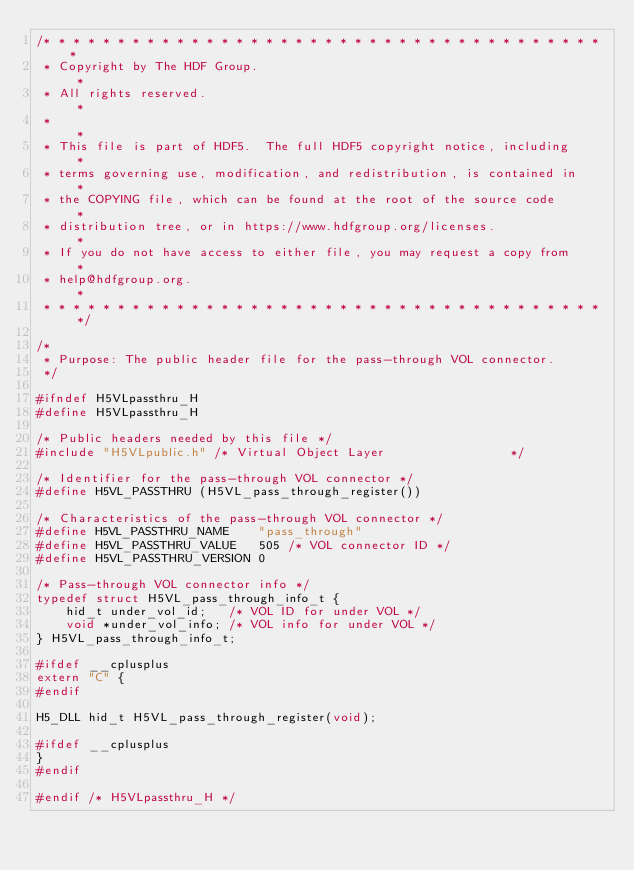Convert code to text. <code><loc_0><loc_0><loc_500><loc_500><_C_>/* * * * * * * * * * * * * * * * * * * * * * * * * * * * * * * * * * * * * * *
 * Copyright by The HDF Group.                                               *
 * All rights reserved.                                                      *
 *                                                                           *
 * This file is part of HDF5.  The full HDF5 copyright notice, including     *
 * terms governing use, modification, and redistribution, is contained in    *
 * the COPYING file, which can be found at the root of the source code       *
 * distribution tree, or in https://www.hdfgroup.org/licenses.               *
 * If you do not have access to either file, you may request a copy from     *
 * help@hdfgroup.org.                                                        *
 * * * * * * * * * * * * * * * * * * * * * * * * * * * * * * * * * * * * * * */

/*
 * Purpose:	The public header file for the pass-through VOL connector.
 */

#ifndef H5VLpassthru_H
#define H5VLpassthru_H

/* Public headers needed by this file */
#include "H5VLpublic.h" /* Virtual Object Layer                 */

/* Identifier for the pass-through VOL connector */
#define H5VL_PASSTHRU (H5VL_pass_through_register())

/* Characteristics of the pass-through VOL connector */
#define H5VL_PASSTHRU_NAME    "pass_through"
#define H5VL_PASSTHRU_VALUE   505 /* VOL connector ID */
#define H5VL_PASSTHRU_VERSION 0

/* Pass-through VOL connector info */
typedef struct H5VL_pass_through_info_t {
    hid_t under_vol_id;   /* VOL ID for under VOL */
    void *under_vol_info; /* VOL info for under VOL */
} H5VL_pass_through_info_t;

#ifdef __cplusplus
extern "C" {
#endif

H5_DLL hid_t H5VL_pass_through_register(void);

#ifdef __cplusplus
}
#endif

#endif /* H5VLpassthru_H */
</code> 